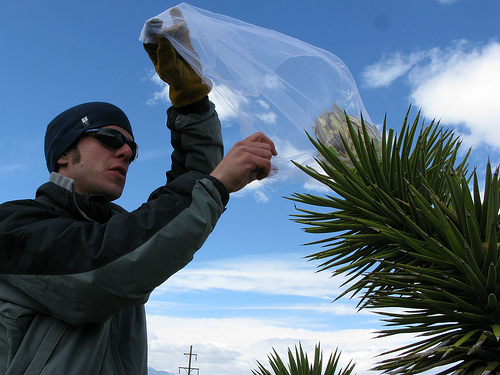<image>
Can you confirm if the netting is on the plant? Yes. Looking at the image, I can see the netting is positioned on top of the plant, with the plant providing support. 